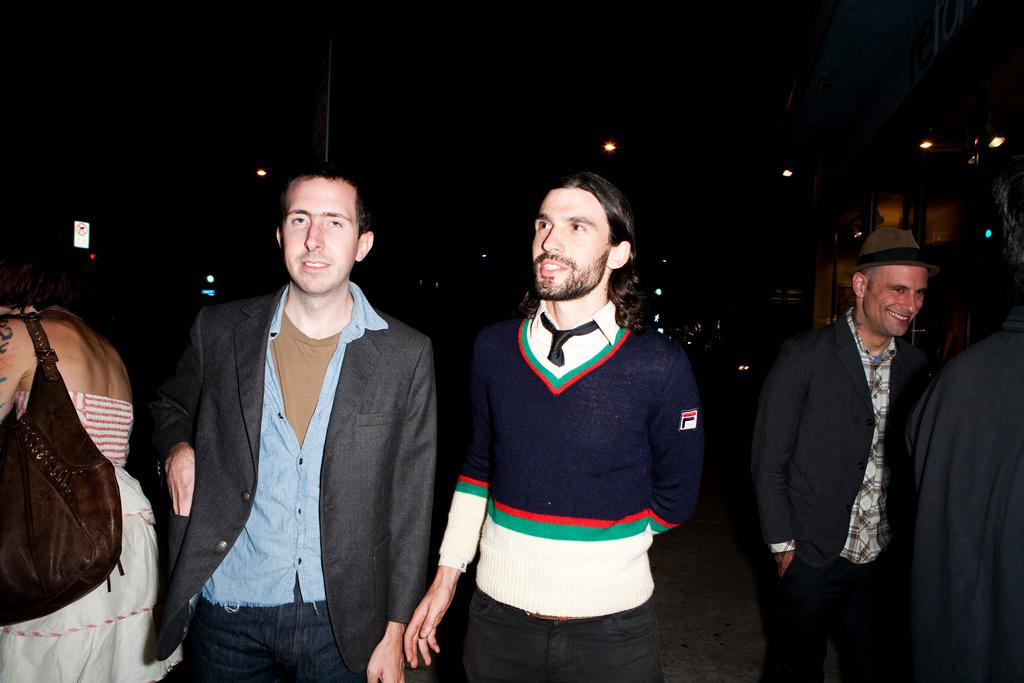Question: what type of dress is the woman wearing?
Choices:
A. A gown.
B. A sundress.
C. A t-length dress.
D. A strapless dress.
Answer with the letter. Answer: D Question: how many people are looking at the camera?
Choices:
A. One.
B. Seven.
C. Eight.
D. Six.
Answer with the letter. Answer: A Question: who has a tattoo?
Choices:
A. The man taking the photo.
B. The person driving the car.
C. The woman with her back to the camera.
D. The tattoo artist.
Answer with the letter. Answer: C Question: how many men are in view?
Choices:
A. One.
B. Two.
C. Three.
D. Four.
Answer with the letter. Answer: C Question: what is on?
Choices:
A. The traffic light.
B. The car engine.
C. A neon light in the pizza shop window.
D. The streetlights.
Answer with the letter. Answer: D Question: what is the man on the right wearing?
Choices:
A. A suit.
B. Sunglasses.
C. A hat.
D. A tie.
Answer with the letter. Answer: D Question: who appears to be happy?
Choices:
A. The gentleman wearing the hat in the far right.
B. The girl with the ice cream.
C. The woman on the left.
D. The boy on the bike.
Answer with the letter. Answer: A Question: who has the tie?
Choices:
A. The third man from the right.
B. The man with a beard and mustache.
C. The overweight man.
D. The little kid.
Answer with the letter. Answer: B Question: how many men have beards?
Choices:
A. Half of them.
B. Seven.
C. One.
D. None.
Answer with the letter. Answer: C Question: who has his left hand behind his back?
Choices:
A. The thin man with the overbite.
B. The man in the blue sweater.
C. The sweating man with the delivery uniform on.
D. The man with the gray beard.
Answer with the letter. Answer: B Question: where are the men walking together?
Choices:
A. In the parking lot.
B. In the street.
C. On the dirt path.
D. On the sidewalk.
Answer with the letter. Answer: D Question: when is the photo taken?
Choices:
A. Day time.
B. Night time.
C. Early evening.
D. Afternoon.
Answer with the letter. Answer: B Question: what color is the hair of the two men?
Choices:
A. Red.
B. White.
C. Brown.
D. Blue.
Answer with the letter. Answer: C Question: what race are the two men?
Choices:
A. African American.
B. Asian.
C. White.
D. Indian.
Answer with the letter. Answer: C Question: when was this taken?
Choices:
A. Early morning.
B. Late afternoon.
C. Dusk.
D. Night time.
Answer with the letter. Answer: D Question: what does the man with the beard have around his neck?
Choices:
A. A scarf.
B. A tie.
C. A snake.
D. A chain.
Answer with the letter. Answer: B Question: what material is the woman's handbag made from?
Choices:
A. Cotton.
B. Denim.
C. Leather.
D. Pleather.
Answer with the letter. Answer: C Question: what is causing the light in the distance?
Choices:
A. Streetlights.
B. The airplane.
C. The approaching automobile.
D. His flashlight.
Answer with the letter. Answer: A Question: who is wearing a striped sleeveless shirt?
Choices:
A. The little boy.
B. Woman.
C. That man.
D. The younger woman.
Answer with the letter. Answer: B 